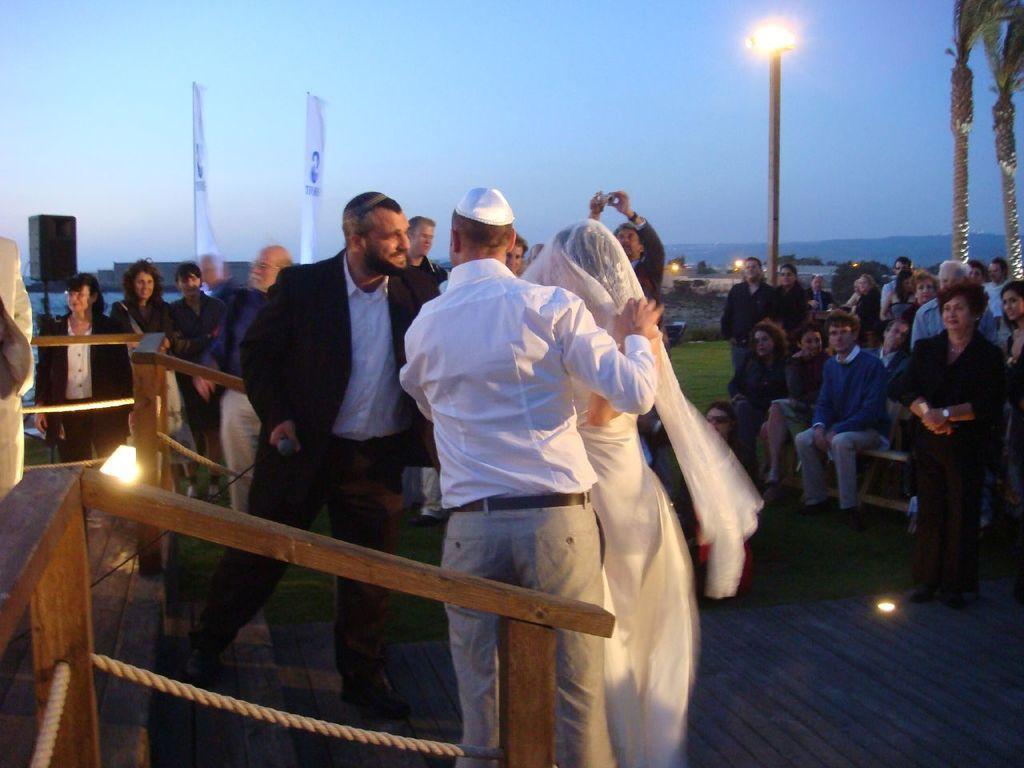Please provide a concise description of this image. In this image we can see a few people, some of them are sitting, there are trees, light pole, light, a speaker, handrail, staircase, and the stage, there are chairs, also we can see the sky. 